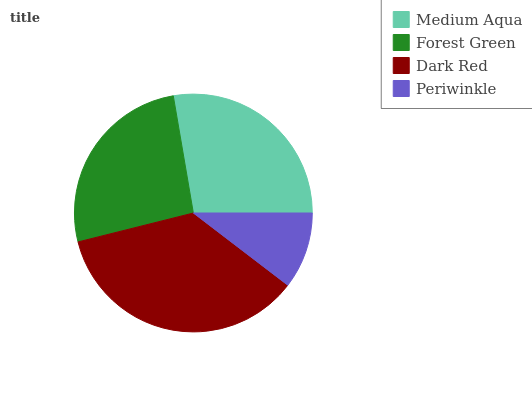Is Periwinkle the minimum?
Answer yes or no. Yes. Is Dark Red the maximum?
Answer yes or no. Yes. Is Forest Green the minimum?
Answer yes or no. No. Is Forest Green the maximum?
Answer yes or no. No. Is Medium Aqua greater than Forest Green?
Answer yes or no. Yes. Is Forest Green less than Medium Aqua?
Answer yes or no. Yes. Is Forest Green greater than Medium Aqua?
Answer yes or no. No. Is Medium Aqua less than Forest Green?
Answer yes or no. No. Is Medium Aqua the high median?
Answer yes or no. Yes. Is Forest Green the low median?
Answer yes or no. Yes. Is Periwinkle the high median?
Answer yes or no. No. Is Medium Aqua the low median?
Answer yes or no. No. 